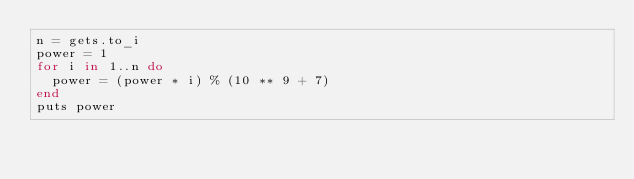Convert code to text. <code><loc_0><loc_0><loc_500><loc_500><_Ruby_>n = gets.to_i
power = 1
for i in 1..n do
  power = (power * i) % (10 ** 9 + 7)
end
puts power
</code> 